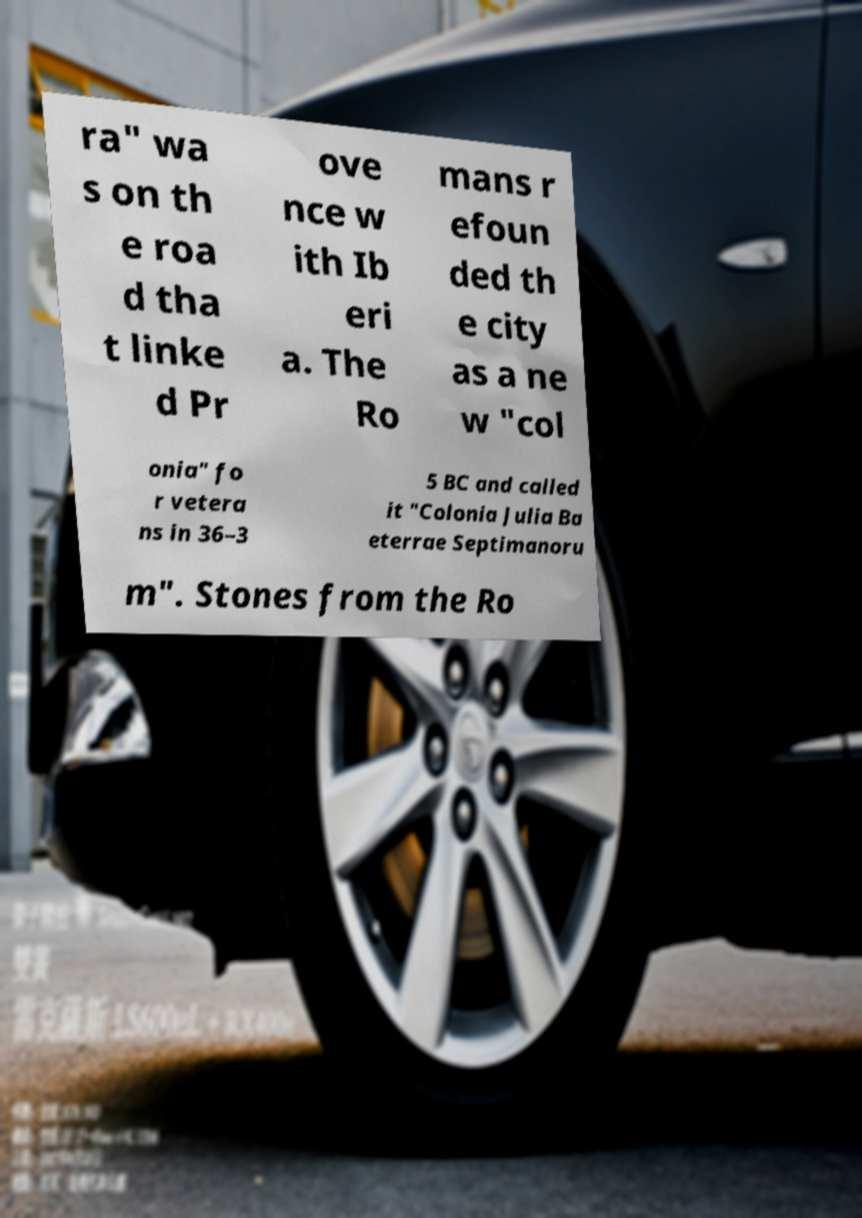There's text embedded in this image that I need extracted. Can you transcribe it verbatim? ra" wa s on th e roa d tha t linke d Pr ove nce w ith Ib eri a. The Ro mans r efoun ded th e city as a ne w "col onia" fo r vetera ns in 36–3 5 BC and called it "Colonia Julia Ba eterrae Septimanoru m". Stones from the Ro 